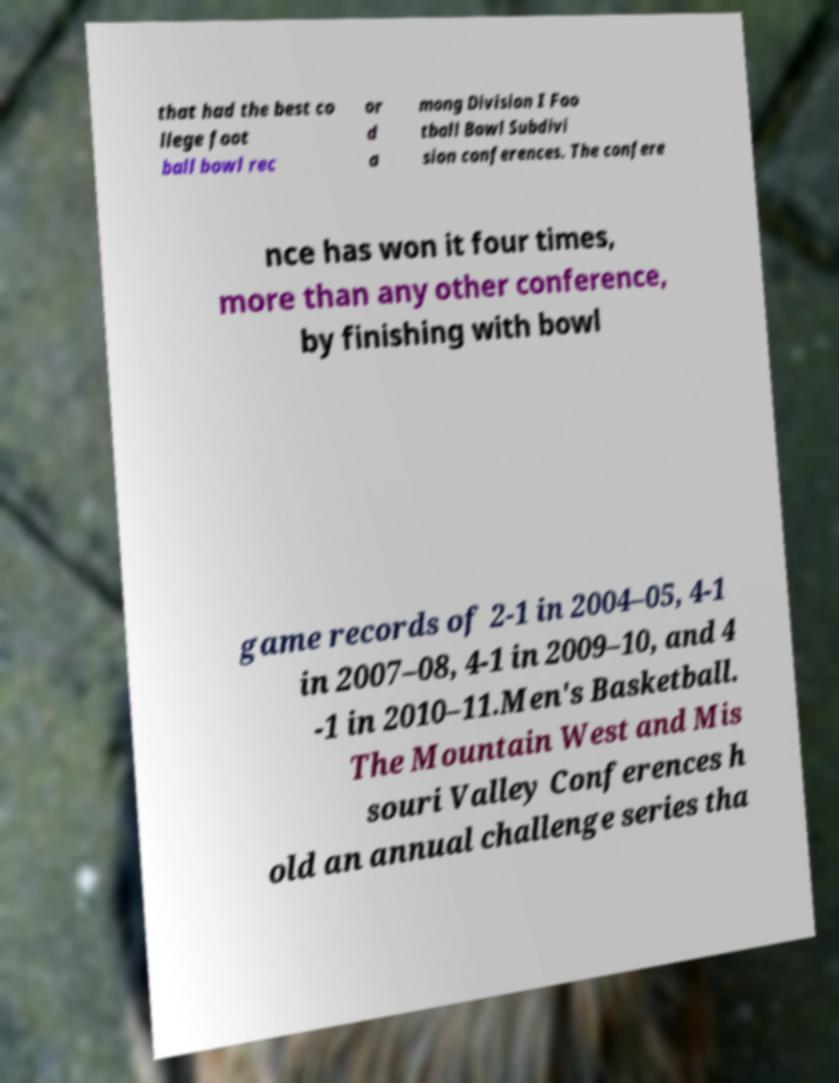What messages or text are displayed in this image? I need them in a readable, typed format. that had the best co llege foot ball bowl rec or d a mong Division I Foo tball Bowl Subdivi sion conferences. The confere nce has won it four times, more than any other conference, by finishing with bowl game records of 2-1 in 2004–05, 4-1 in 2007–08, 4-1 in 2009–10, and 4 -1 in 2010–11.Men's Basketball. The Mountain West and Mis souri Valley Conferences h old an annual challenge series tha 